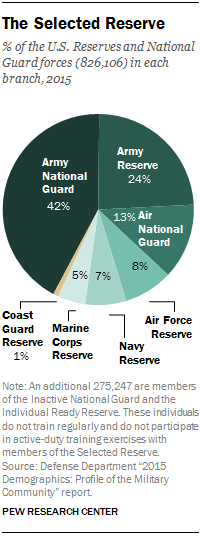Draw attention to some important aspects in this diagram. Yes, the total percentage of Coast Guard Reserve, Marine Corps Reserve, and Navy Reserve is equal to the percentage of Air National Guard. The Army Reserve comprises 0.24% of the total Army personnel. 